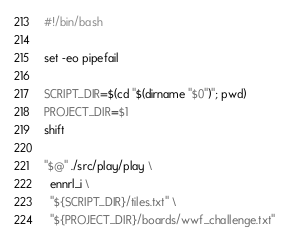<code> <loc_0><loc_0><loc_500><loc_500><_Bash_>#!/bin/bash

set -eo pipefail

SCRIPT_DIR=$(cd "$(dirname "$0")"; pwd)
PROJECT_DIR=$1
shift

"$@" ./src/play/play \
  ennrl_i \
  "${SCRIPT_DIR}/tiles.txt" \
  "${PROJECT_DIR}/boards/wwf_challenge.txt" 
</code> 